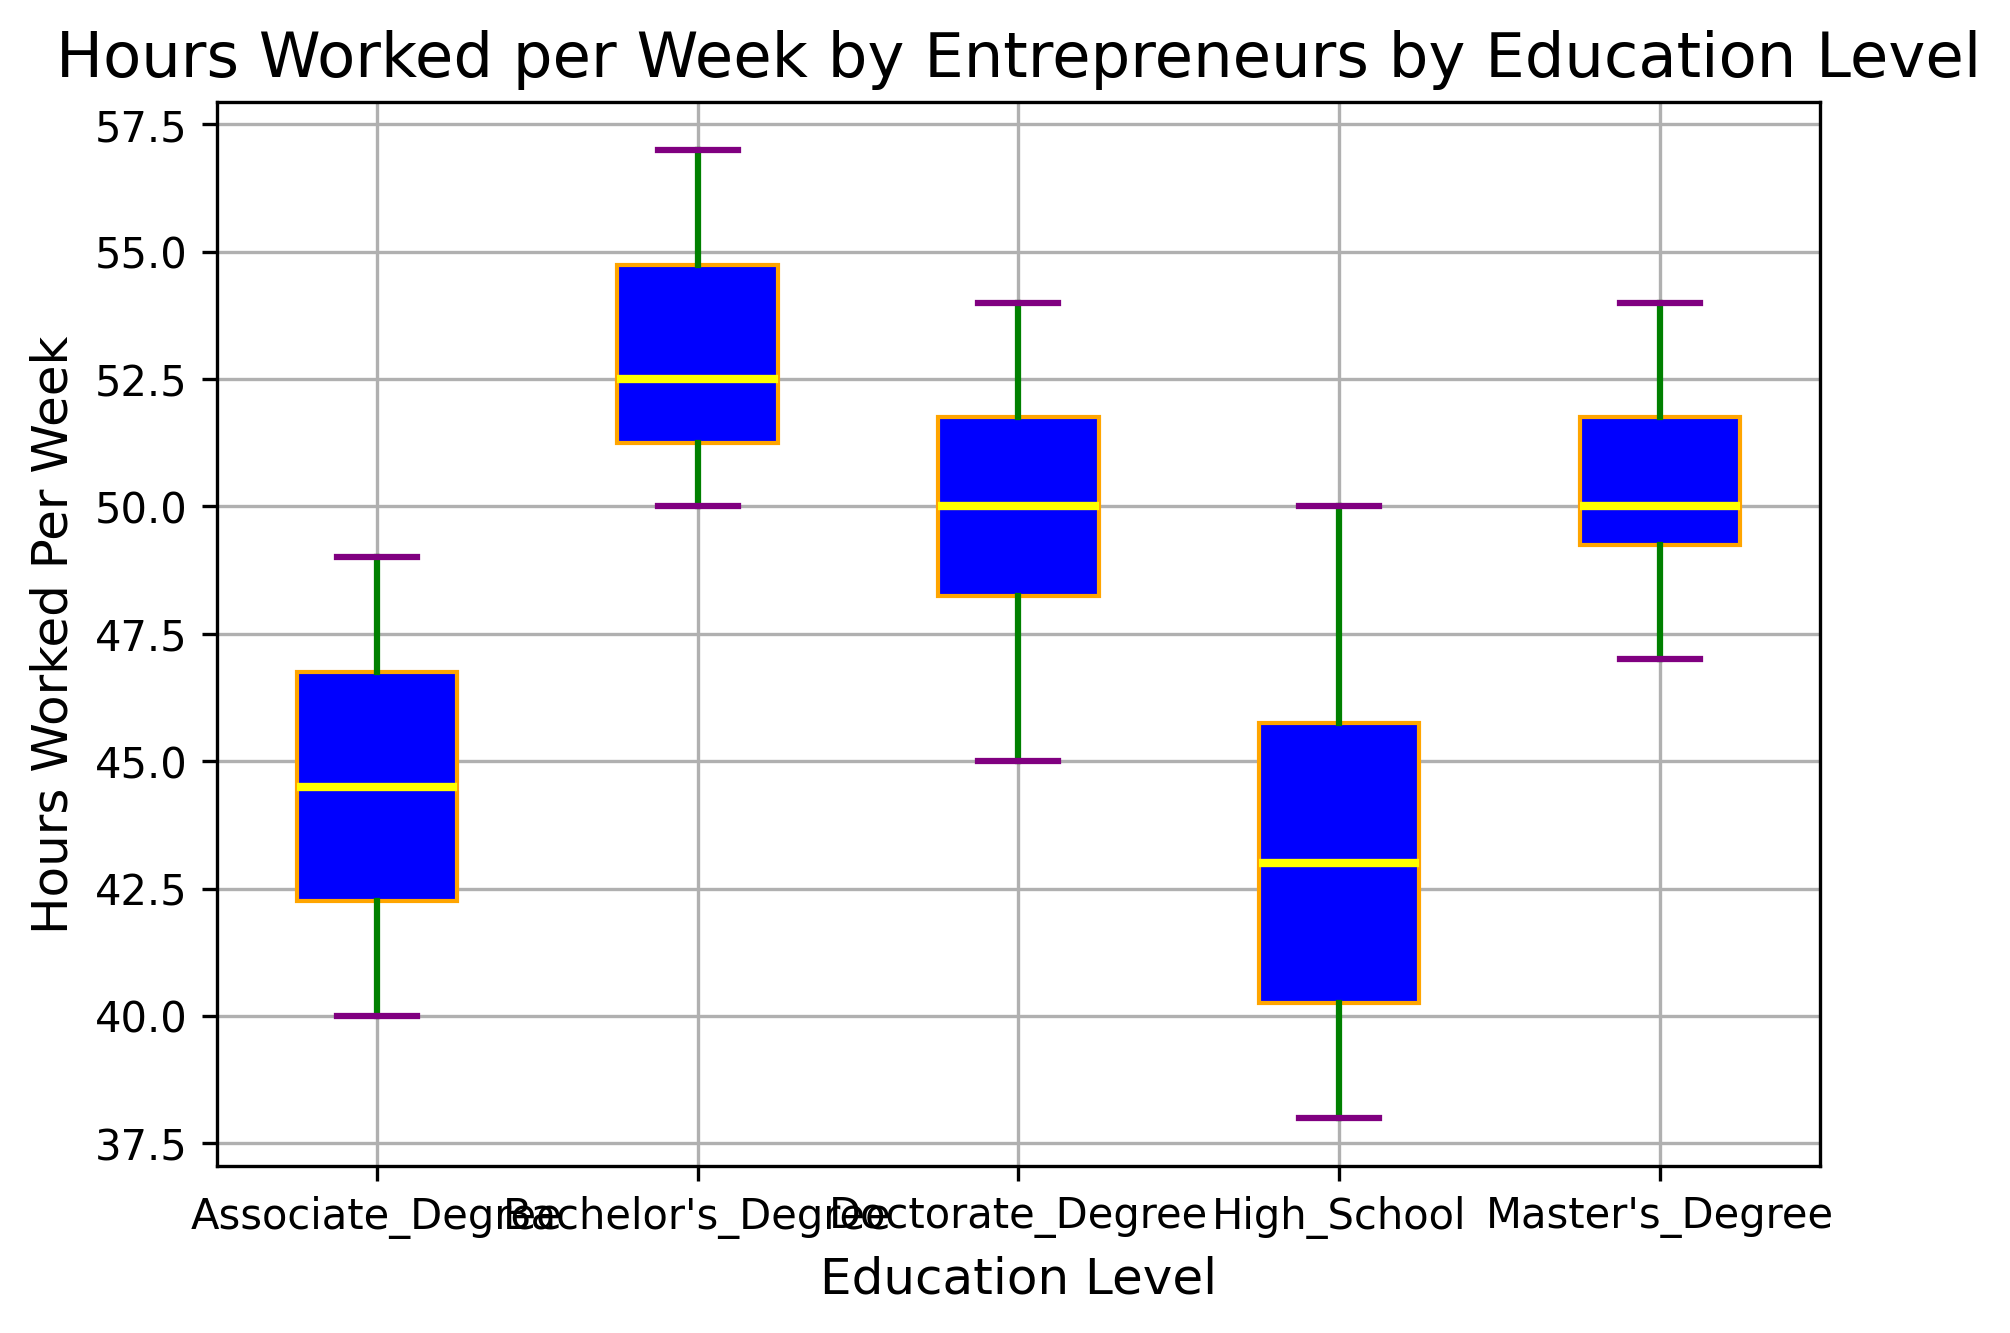What is the median number of hours worked per week by entrepreneurs with a Bachelor's Degree? To find the median number of hours worked per week by entrepreneurs with a Bachelor's Degree, reference the line within the box for the Bachelor's Degree category. The median is indicated by the yellow line within the box.
Answer: 52 Which education level shows the highest median number of hours worked per week? Compare the median lines (yellow) across all the education level categories. The highest median line identifies the education level with the highest median number of hours worked per week.
Answer: Bachelor's Degree Is there more variation in hours worked per week among entrepreneurs with a High School education or a Master's Degree? To determine the variation, look at the length of the boxes (interquartile range) and the whiskers. A larger box and longer whiskers indicate more variation.
Answer: High School What is the median number of hours worked per week for entrepreneurs with a Doctorate Degree? The median for a Doctorate Degree can be found by locating the yellow line within the box corresponding to the Doctorate Degree category.
Answer: 50 Which education level has the smallest range of hours worked per week? The range is the difference between the smallest and largest values represented by the whiskers. Compare the lengths of the whiskers across all education levels to find the smallest range.
Answer: Doctorate Degree Compare the median hours worked per week between Bachelor's Degree and Associate Degree. Identify the yellow median lines within the boxes of both Bachelor's Degree and Associate Degree categories and compare their positions.
Answer: Bachelor's Degree: 52, Associate Degree: 45 Which education level's participants have the highest maximum number of hours worked per week? Locate the highest point of the top whiskers across all education levels to find the highest maximum number of hours worked.
Answer: Bachelor's Degree What is the interquartile range (IQR) for High School educated entrepreneurs? The IQR is the difference between the first quartile (Q1) and the third quartile (Q3). Measure the distance between the bottom and top parts of the box for the High School category.
Answer: 44 - 39 = 5 How does the median hours worked per week for entrepreneurs with a Master's Degree compare to those with a Doctorate Degree? Compare the positions of the yellow median lines within the boxes for Master's Degree and Doctorate Degree categories.
Answer: Master's Degree: 50, Doctorate Degree: 50 Which education level appears to have outliers in the hours worked per week? Outliers are indicated by red points outside the whiskers. Identify any red points outside the whiskers in the figure.
Answer: None 